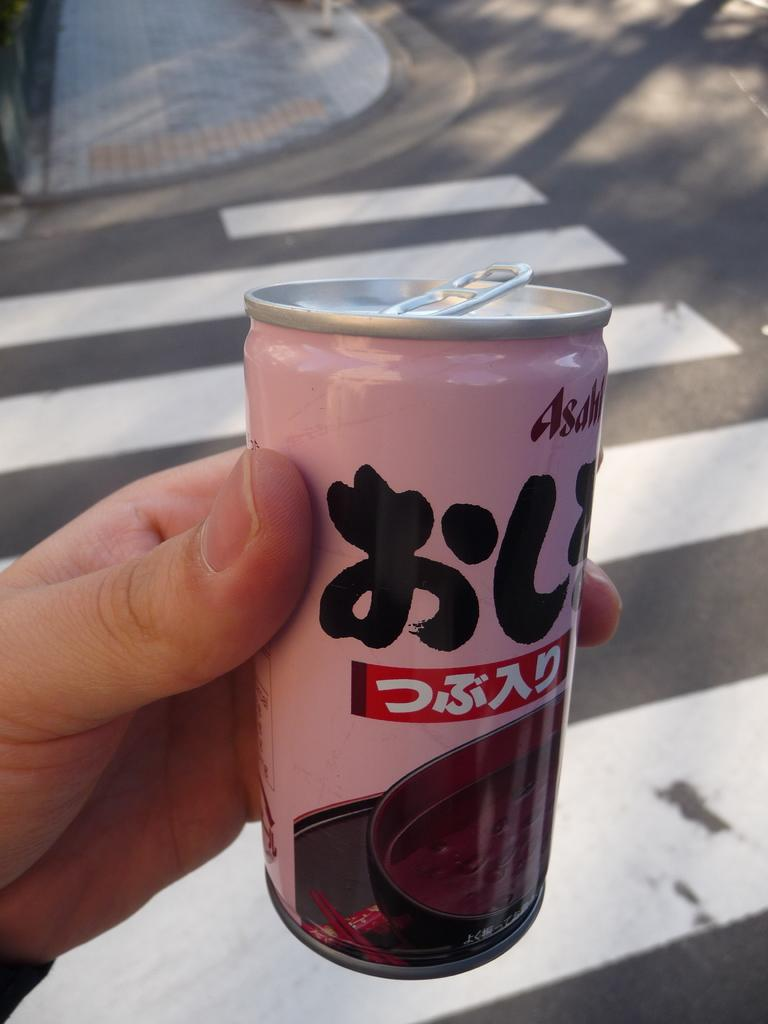What is the human hand holding in the image? The human hand is holding a bottle in the image. What can be seen in the background of the image? There is a road visible in the background of the image. What type of picture is the human hand holding in the image? The human hand is not holding a picture in the image; it is holding a bottle. 